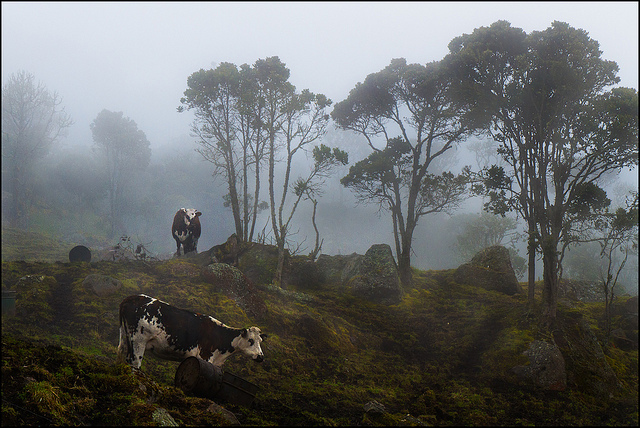<image>What is the dog doing? I don't know what the dog is doing as there appears to be no dog in the picture. What is the dog doing? I don't know what the dog is doing. It can be seen walking or barking. 